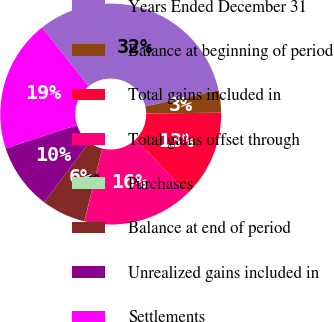<chart> <loc_0><loc_0><loc_500><loc_500><pie_chart><fcel>Years Ended December 31<fcel>Balance at beginning of period<fcel>Total gains included in<fcel>Total gains offset through<fcel>Purchases<fcel>Balance at end of period<fcel>Unrealized gains included in<fcel>Settlements<nl><fcel>32.23%<fcel>3.24%<fcel>12.9%<fcel>16.12%<fcel>0.02%<fcel>6.46%<fcel>9.68%<fcel>19.35%<nl></chart> 